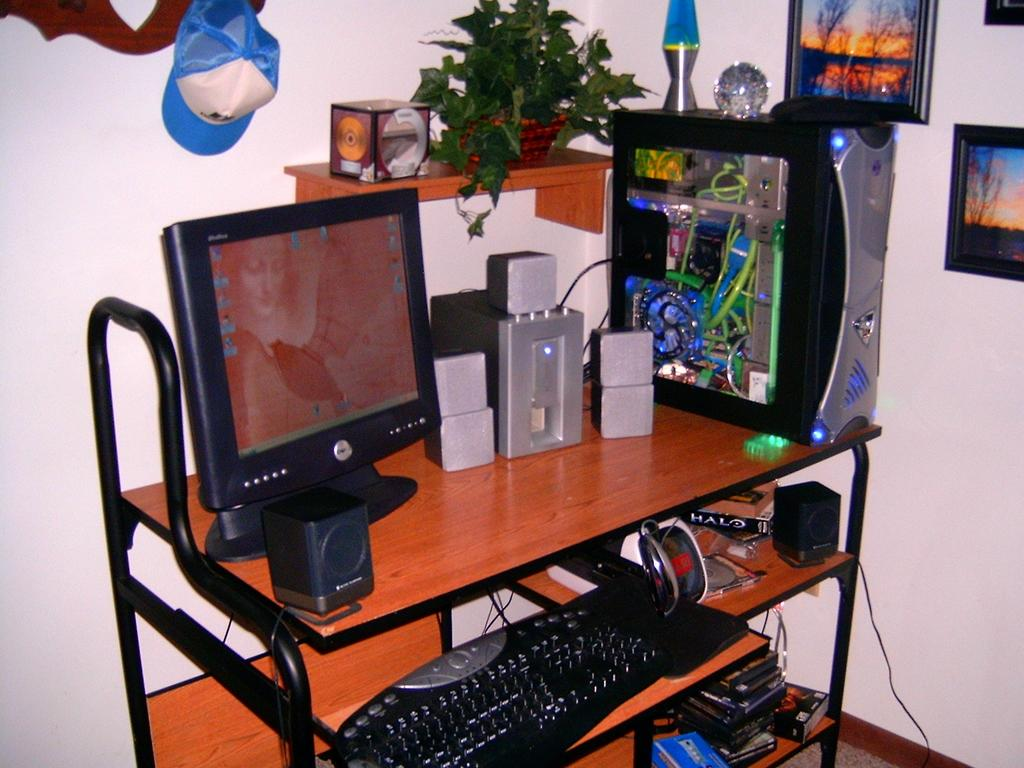What electronic device is present in the image? There is a computer in the image. What is used to input commands into the computer? There is a keyboard in the image. What is used to produce sound from the computer? There are speakers in the image. Where are the computer, keyboard, and speakers located? They are on a table in the image. What can be seen behind the computer table? There is a wall behind the computer table. What type of clothing accessory is visible in the image? There is a cap visible in the image. How many sheep are visible in the image? There are no sheep present in the image. What is the edge of the table used for in the image? There is no mention of an edge of the table in the image, and its purpose cannot be determined from the provided facts. 